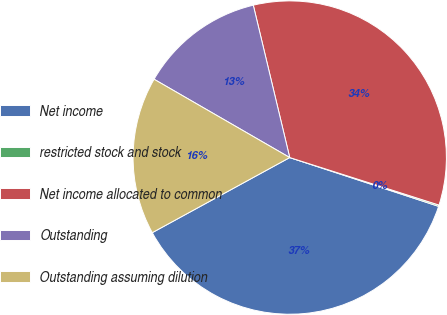Convert chart. <chart><loc_0><loc_0><loc_500><loc_500><pie_chart><fcel>Net income<fcel>restricted stock and stock<fcel>Net income allocated to common<fcel>Outstanding<fcel>Outstanding assuming dilution<nl><fcel>37.0%<fcel>0.14%<fcel>33.64%<fcel>12.93%<fcel>16.29%<nl></chart> 